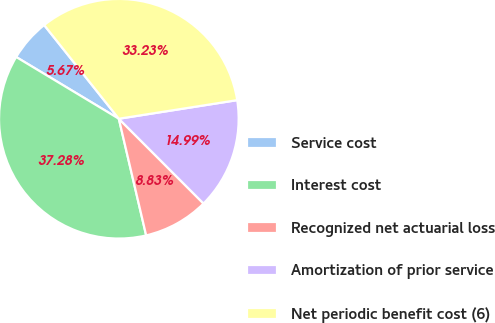<chart> <loc_0><loc_0><loc_500><loc_500><pie_chart><fcel>Service cost<fcel>Interest cost<fcel>Recognized net actuarial loss<fcel>Amortization of prior service<fcel>Net periodic benefit cost (6)<nl><fcel>5.67%<fcel>37.28%<fcel>8.83%<fcel>14.99%<fcel>33.23%<nl></chart> 